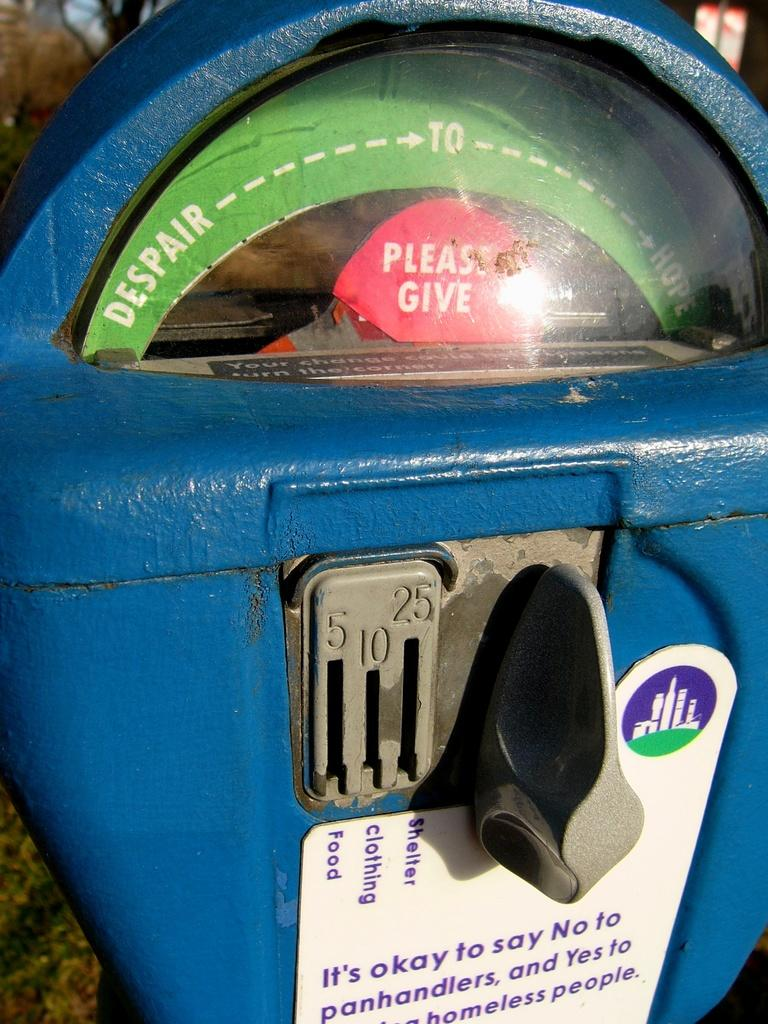<image>
Provide a brief description of the given image. A donation meter where you can give using 5, 10, or 25 cent coins 